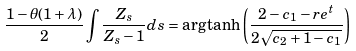Convert formula to latex. <formula><loc_0><loc_0><loc_500><loc_500>\frac { 1 - \theta ( 1 + \lambda ) } { 2 } \int \frac { Z _ { s } } { Z _ { s } - 1 } d s = \arg \tanh \left ( \frac { 2 - c _ { 1 } - r e ^ { t } } { 2 \sqrt { c _ { 2 } + 1 - c _ { 1 } } } \right )</formula> 